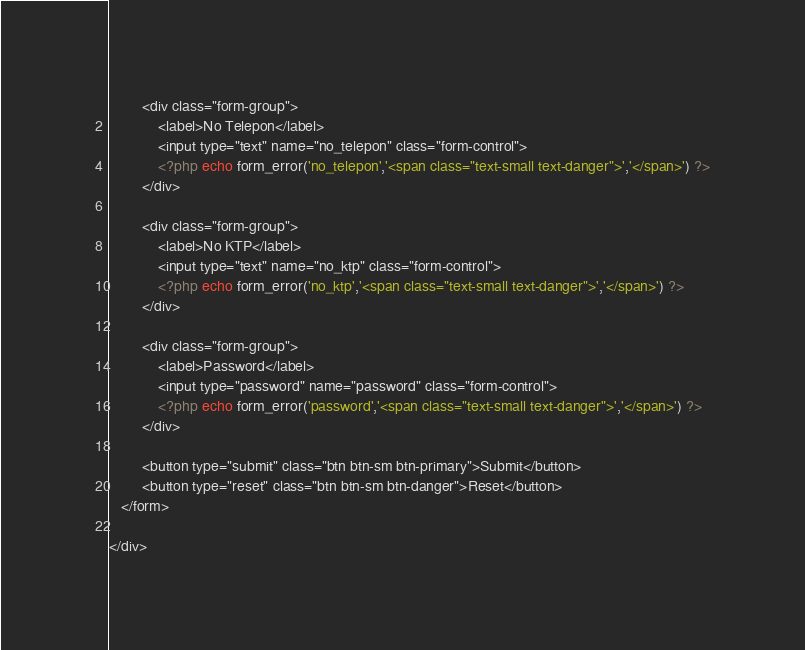Convert code to text. <code><loc_0><loc_0><loc_500><loc_500><_PHP_>
   		<div class="form-group">
   			<label>No Telepon</label>
   			<input type="text" name="no_telepon" class="form-control">
   			<?php echo form_error('no_telepon','<span class="text-small text-danger">','</span>') ?>
   		</div>

   		<div class="form-group">
   			<label>No KTP</label>
   			<input type="text" name="no_ktp" class="form-control">
   			<?php echo form_error('no_ktp','<span class="text-small text-danger">','</span>') ?>
   		</div>

   		<div class="form-group">
   			<label>Password</label>
   			<input type="password" name="password" class="form-control">
   			<?php echo form_error('password','<span class="text-small text-danger">','</span>') ?>
   		</div>

   		<button type="submit" class="btn btn-sm btn-primary">Submit</button>
   		<button type="reset" class="btn btn-sm btn-danger">Reset</button>
   </form>

</div></code> 